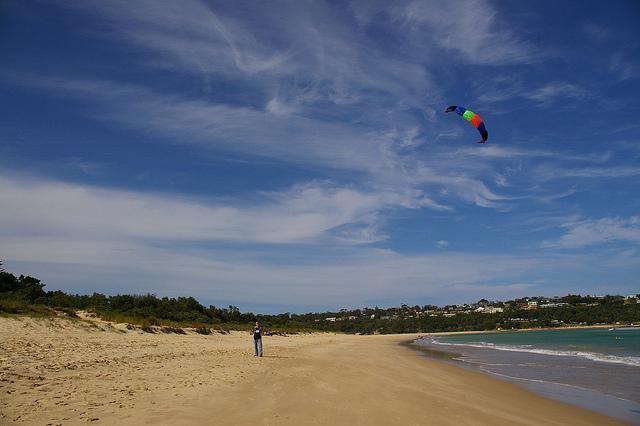How many dogs are there with brown color?
Give a very brief answer. 0. 